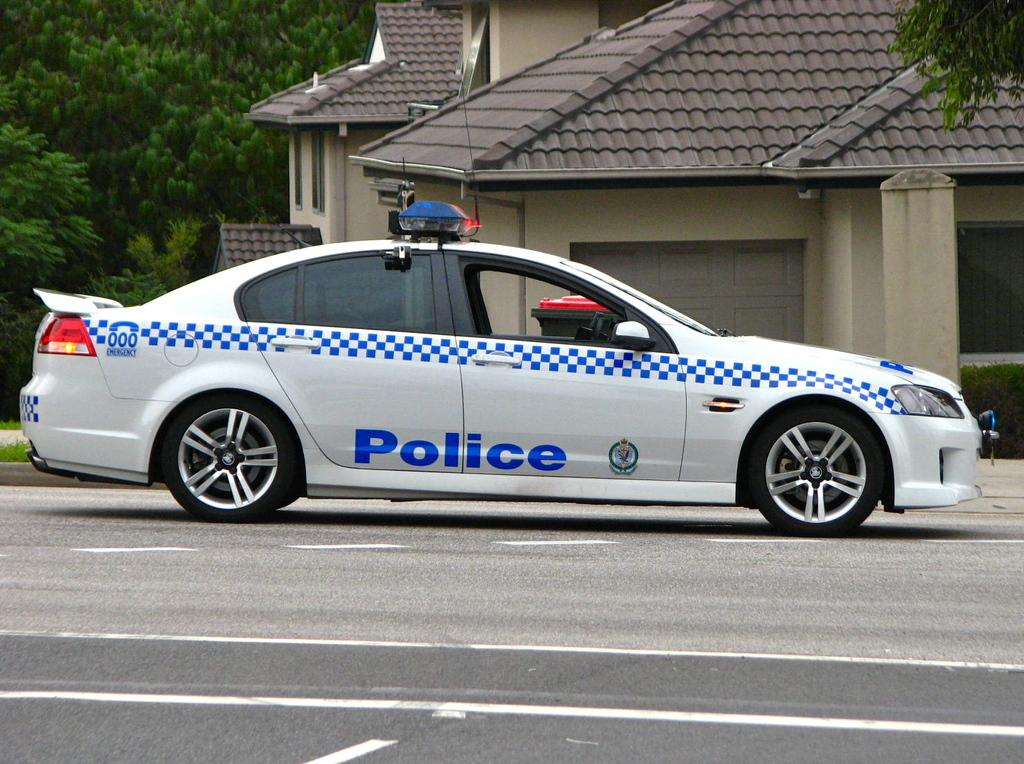What type of vehicle is in the image? There is a police car in the image. What colors are used on the police car? The police car is white and blue. Where is the police car located in the image? The police car is on the road. What can be seen in the background of the image? There are houses and trees in the background of the image. What joke is the maid telling to the mom in the image? There is no maid or mom present in the image; it features a police car on the road with houses and trees in the background. 